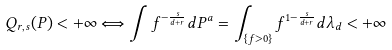Convert formula to latex. <formula><loc_0><loc_0><loc_500><loc_500>Q _ { r , s } ( P ) < + \infty \Longleftrightarrow \int f ^ { - \frac { s } { d + r } } d P ^ { a } = \int _ { \{ f > 0 \} } f ^ { 1 - \frac { s } { d + r } } d \lambda _ { d } < + \infty</formula> 